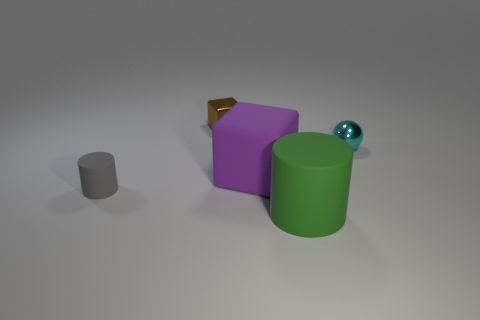Add 2 big objects. How many objects exist? 7 Subtract all cylinders. How many objects are left? 3 Subtract all large purple objects. Subtract all shiny balls. How many objects are left? 3 Add 5 gray matte cylinders. How many gray matte cylinders are left? 6 Add 1 small red metallic things. How many small red metallic things exist? 1 Subtract 1 brown cubes. How many objects are left? 4 